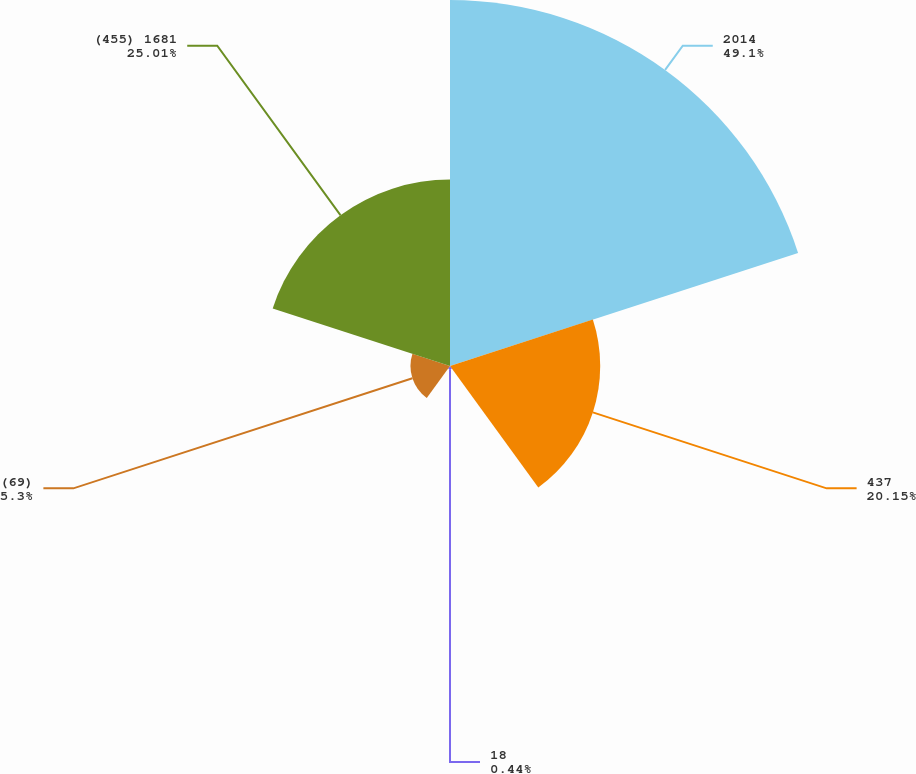<chart> <loc_0><loc_0><loc_500><loc_500><pie_chart><fcel>2014<fcel>437<fcel>18<fcel>(69)<fcel>(455) 1681<nl><fcel>49.1%<fcel>20.15%<fcel>0.44%<fcel>5.3%<fcel>25.01%<nl></chart> 